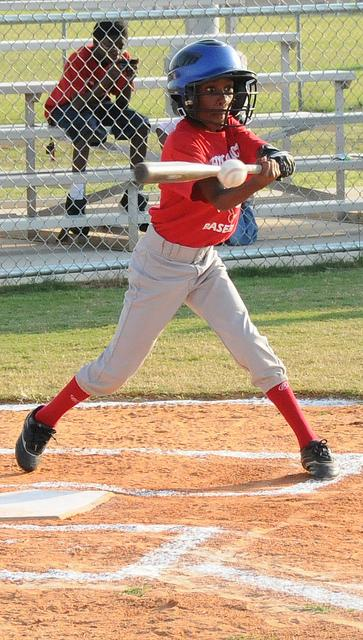What team wears similar socks to the boy in the foreground? red sox 